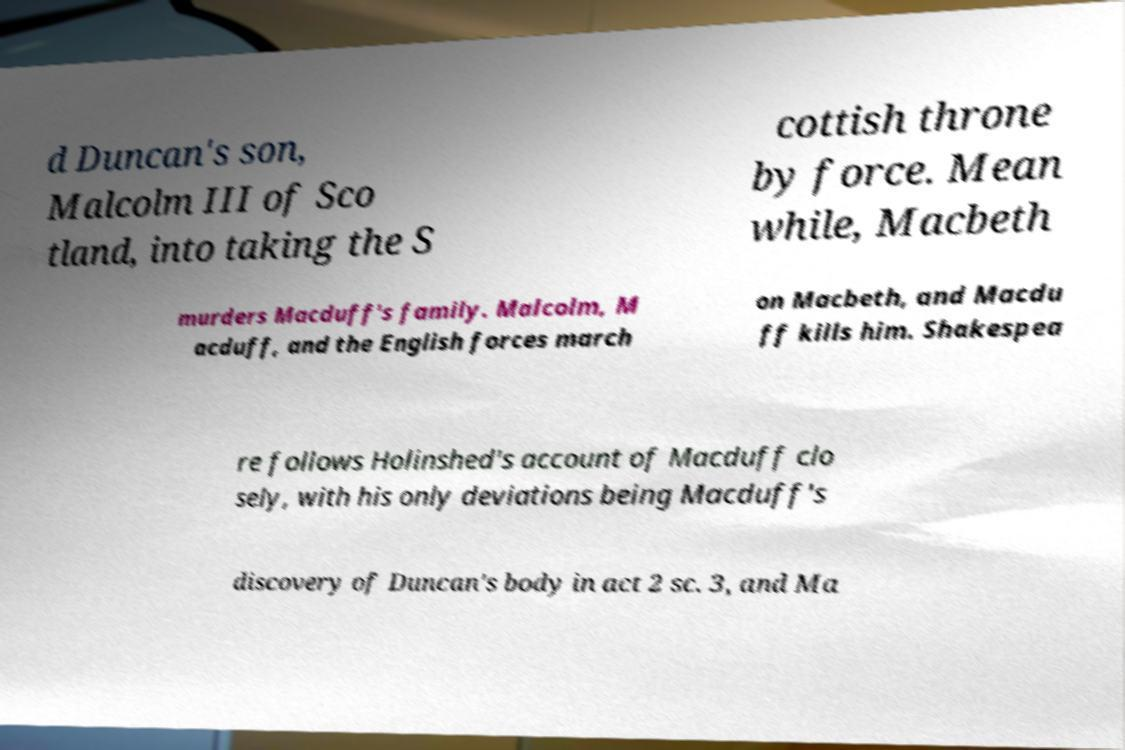Can you read and provide the text displayed in the image?This photo seems to have some interesting text. Can you extract and type it out for me? d Duncan's son, Malcolm III of Sco tland, into taking the S cottish throne by force. Mean while, Macbeth murders Macduff's family. Malcolm, M acduff, and the English forces march on Macbeth, and Macdu ff kills him. Shakespea re follows Holinshed's account of Macduff clo sely, with his only deviations being Macduff's discovery of Duncan's body in act 2 sc. 3, and Ma 